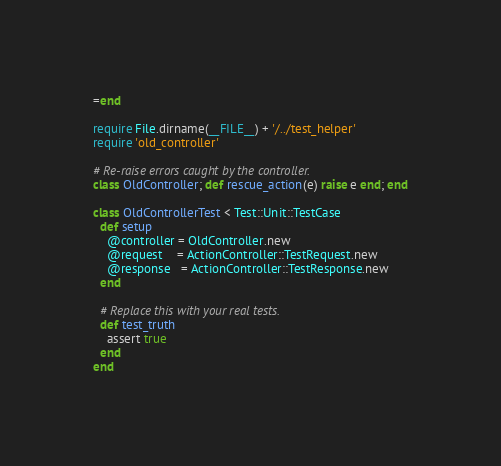Convert code to text. <code><loc_0><loc_0><loc_500><loc_500><_Ruby_>=end

require File.dirname(__FILE__) + '/../test_helper'
require 'old_controller'

# Re-raise errors caught by the controller.
class OldController; def rescue_action(e) raise e end; end

class OldControllerTest < Test::Unit::TestCase
  def setup
    @controller = OldController.new
    @request    = ActionController::TestRequest.new
    @response   = ActionController::TestResponse.new
  end

  # Replace this with your real tests.
  def test_truth
    assert true
  end
end
</code> 